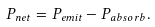<formula> <loc_0><loc_0><loc_500><loc_500>P _ { n e t } = P _ { e m i t } - P _ { a b s o r b } .</formula> 